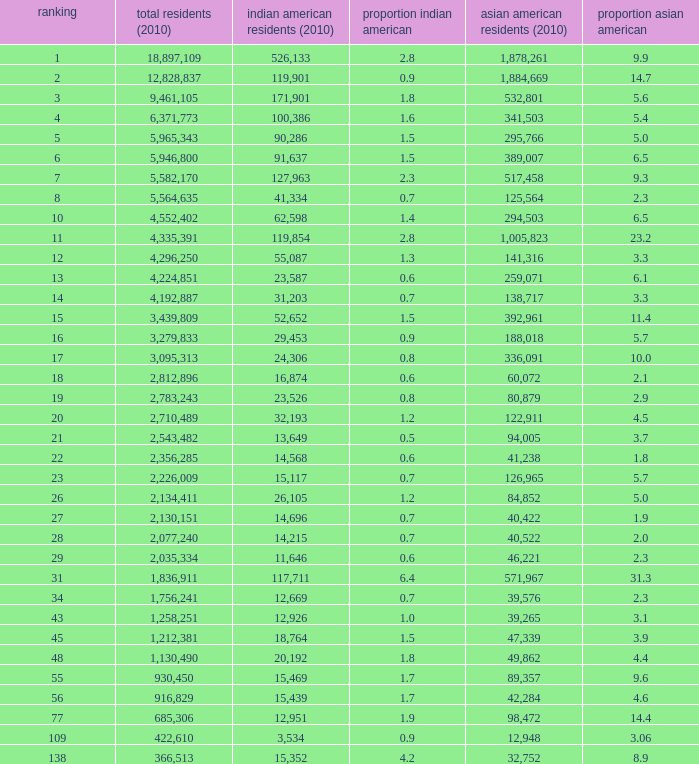What's the total population when there are 5.7% Asian American and fewer than 126,965 Asian American Population? None. 